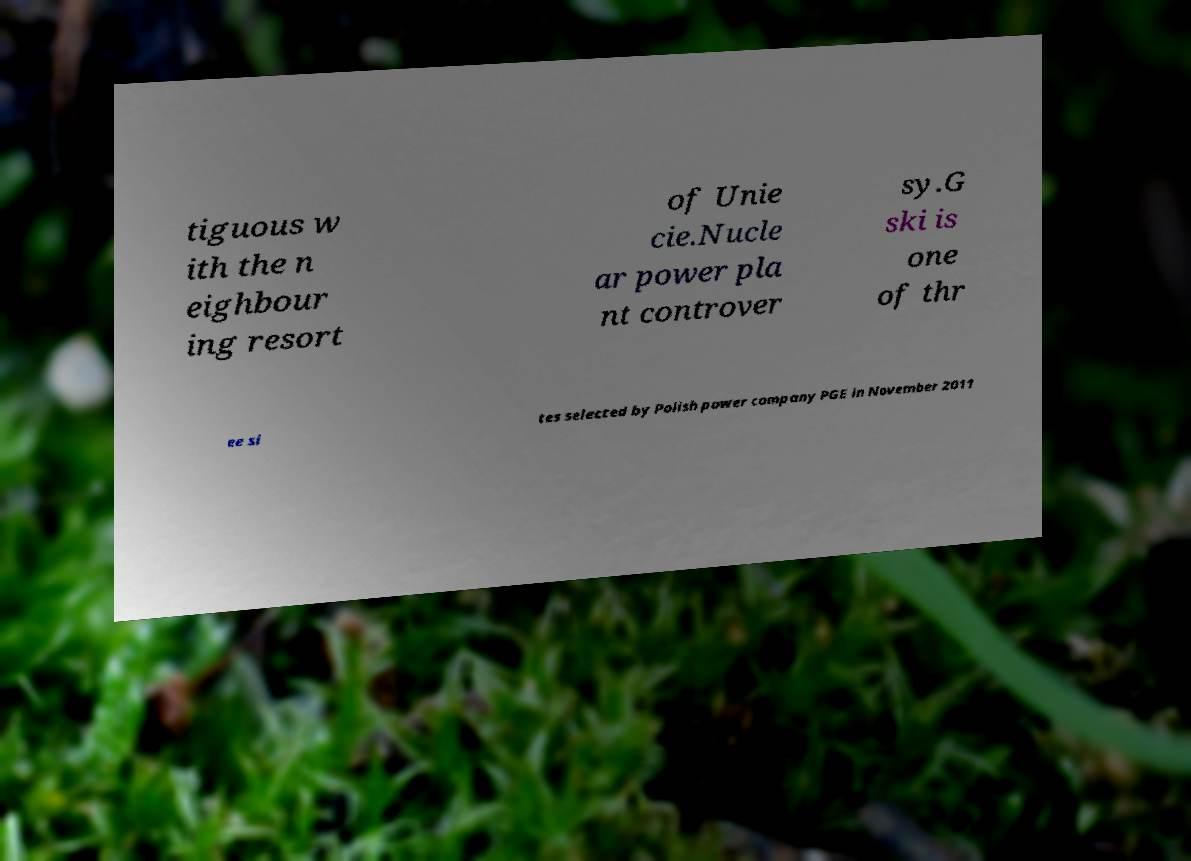Can you read and provide the text displayed in the image?This photo seems to have some interesting text. Can you extract and type it out for me? tiguous w ith the n eighbour ing resort of Unie cie.Nucle ar power pla nt controver sy.G ski is one of thr ee si tes selected by Polish power company PGE in November 2011 